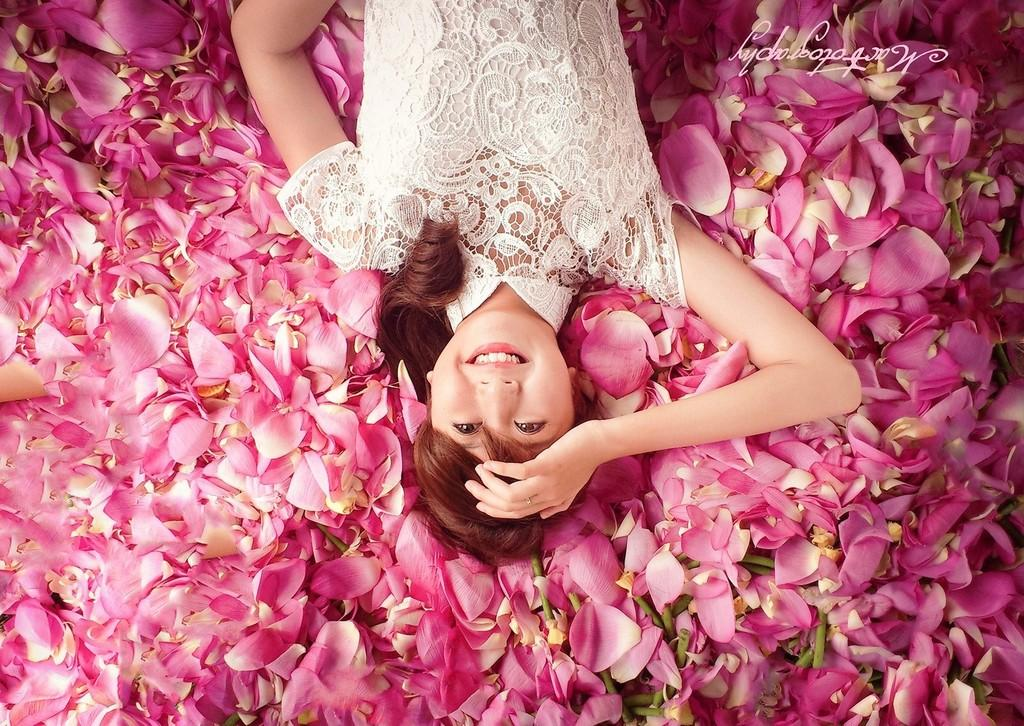Who is present in the image? There is a woman in the image. What is the woman wearing? The woman is wearing a white dress. What is the woman doing in the image? The woman is laying on rose petals. What is the woman's facial expression? The woman is smiling. What can be seen at the bottom of the image? Rose petals are present at the bottom of the image. Where is the text located in the image? There is text in the top right corner of the image. Can you see a mountain in the background of the image? There is no mountain visible in the image. What type of cream is being used to make the woman's dress in the image? The woman's dress is white, but there is no mention of cream being used in the image. 